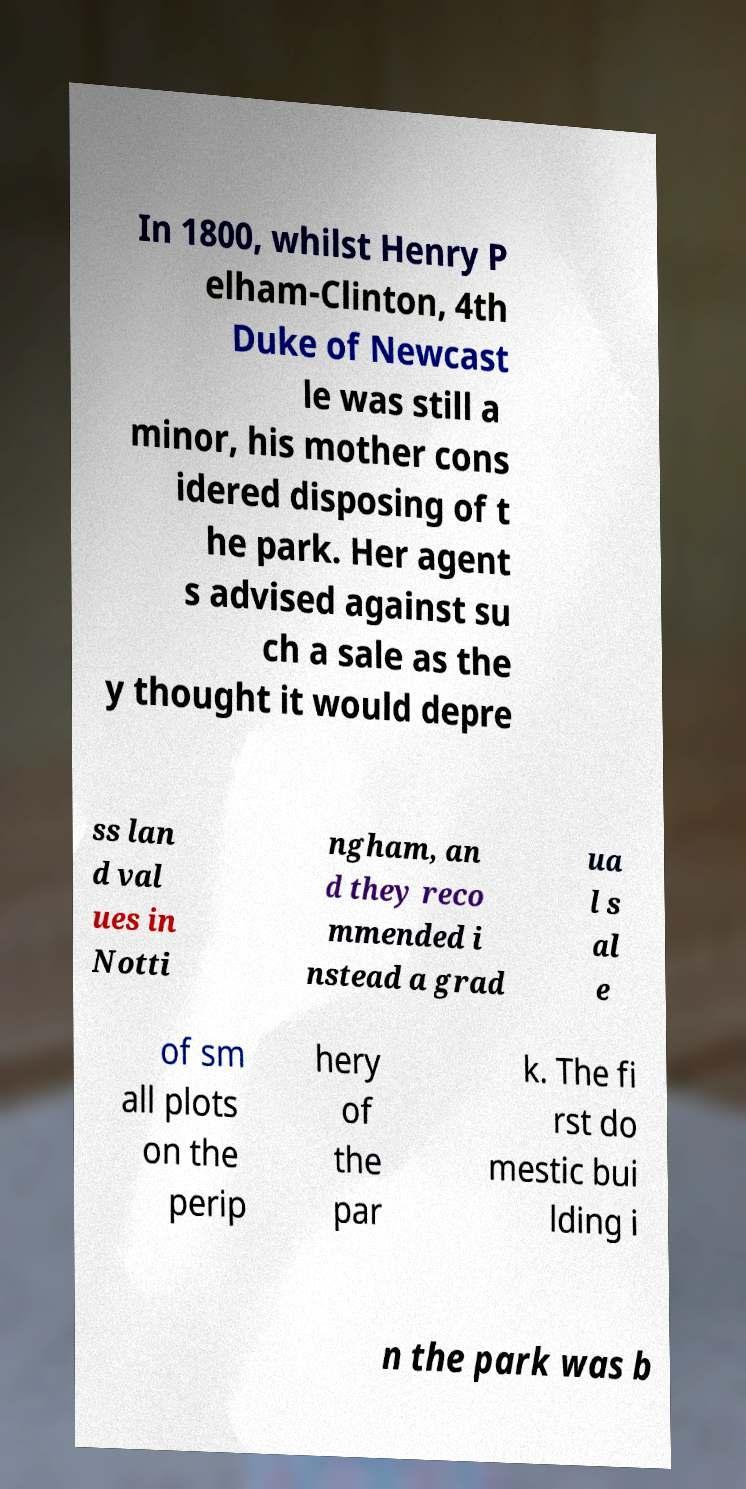What messages or text are displayed in this image? I need them in a readable, typed format. In 1800, whilst Henry P elham-Clinton, 4th Duke of Newcast le was still a minor, his mother cons idered disposing of t he park. Her agent s advised against su ch a sale as the y thought it would depre ss lan d val ues in Notti ngham, an d they reco mmended i nstead a grad ua l s al e of sm all plots on the perip hery of the par k. The fi rst do mestic bui lding i n the park was b 